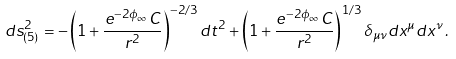Convert formula to latex. <formula><loc_0><loc_0><loc_500><loc_500>d s ^ { 2 } _ { ( 5 ) } = - \left ( 1 + \frac { e ^ { - 2 \phi _ { \infty } } C } { r ^ { 2 } } \right ) ^ { - 2 / 3 } d t ^ { 2 } + \left ( 1 + \frac { e ^ { - 2 \phi _ { \infty } } C } { r ^ { 2 } } \right ) ^ { 1 / 3 } \delta _ { \mu \nu } d x ^ { \mu } d x ^ { \nu } \, .</formula> 